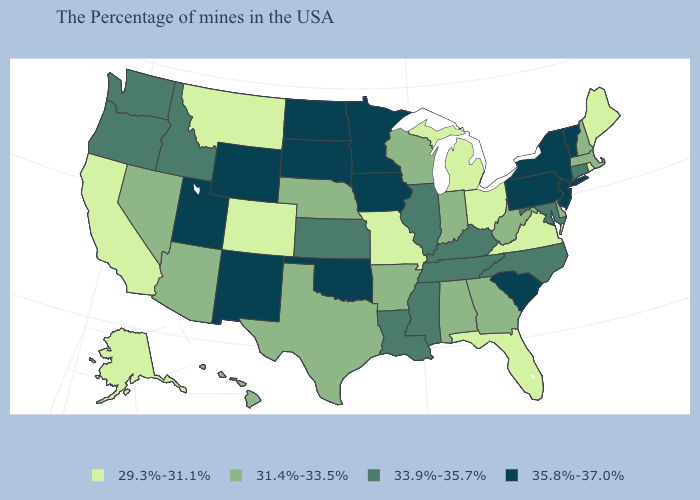Does Washington have a higher value than South Carolina?
Quick response, please. No. Does the map have missing data?
Concise answer only. No. Which states have the lowest value in the West?
Short answer required. Colorado, Montana, California, Alaska. Does Ohio have the highest value in the MidWest?
Quick response, please. No. Among the states that border Connecticut , which have the highest value?
Concise answer only. New York. Name the states that have a value in the range 31.4%-33.5%?
Write a very short answer. Massachusetts, New Hampshire, Delaware, West Virginia, Georgia, Indiana, Alabama, Wisconsin, Arkansas, Nebraska, Texas, Arizona, Nevada, Hawaii. Name the states that have a value in the range 29.3%-31.1%?
Write a very short answer. Maine, Rhode Island, Virginia, Ohio, Florida, Michigan, Missouri, Colorado, Montana, California, Alaska. Which states have the lowest value in the USA?
Give a very brief answer. Maine, Rhode Island, Virginia, Ohio, Florida, Michigan, Missouri, Colorado, Montana, California, Alaska. Name the states that have a value in the range 31.4%-33.5%?
Quick response, please. Massachusetts, New Hampshire, Delaware, West Virginia, Georgia, Indiana, Alabama, Wisconsin, Arkansas, Nebraska, Texas, Arizona, Nevada, Hawaii. Name the states that have a value in the range 35.8%-37.0%?
Give a very brief answer. Vermont, New York, New Jersey, Pennsylvania, South Carolina, Minnesota, Iowa, Oklahoma, South Dakota, North Dakota, Wyoming, New Mexico, Utah. What is the value of Florida?
Quick response, please. 29.3%-31.1%. Name the states that have a value in the range 29.3%-31.1%?
Keep it brief. Maine, Rhode Island, Virginia, Ohio, Florida, Michigan, Missouri, Colorado, Montana, California, Alaska. Does the map have missing data?
Answer briefly. No. Among the states that border Rhode Island , which have the highest value?
Give a very brief answer. Connecticut. Among the states that border Michigan , does Indiana have the lowest value?
Write a very short answer. No. 